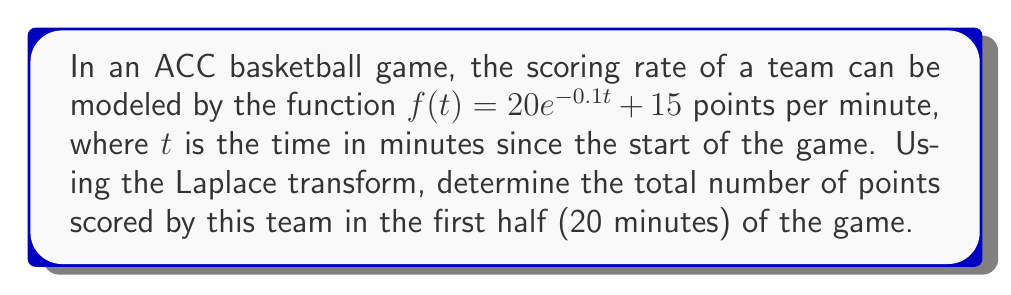Could you help me with this problem? Let's approach this problem step-by-step using Laplace transforms:

1) First, we need to find the Laplace transform of $f(t)$:

   $\mathcal{L}\{f(t)\} = \mathcal{L}\{20e^{-0.1t} + 15\}$

2) Using linearity property of Laplace transform:

   $\mathcal{L}\{f(t)\} = 20\mathcal{L}\{e^{-0.1t}\} + 15\mathcal{L}\{1\}$

3) We know that:
   $\mathcal{L}\{e^{at}\} = \frac{1}{s-a}$ and $\mathcal{L}\{1\} = \frac{1}{s}$

4) Applying these:

   $F(s) = \frac{20}{s+0.1} + \frac{15}{s}$

5) To find the total points scored, we need to integrate $f(t)$ from 0 to 20:

   $\int_0^{20} f(t) dt = \mathcal{L}^{-1}\{\frac{F(s)}{s}\}|_{t=20}$

6) Let's calculate $\frac{F(s)}{s}$:

   $\frac{F(s)}{s} = \frac{20}{s(s+0.1)} + \frac{15}{s^2}$

7) Taking the inverse Laplace transform:

   $\mathcal{L}^{-1}\{\frac{F(s)}{s}\} = 200(1-e^{-0.1t}) + 15t$

8) Evaluating at t = 20:

   $200(1-e^{-0.1(20)}) + 15(20) = 200(1-e^{-2}) + 300$

9) Calculate the final result:

   $200(1-0.1353) + 300 = 200(0.8647) + 300 = 172.94 + 300 = 472.94$
Answer: The team scores approximately 473 points in the first half of the game. 